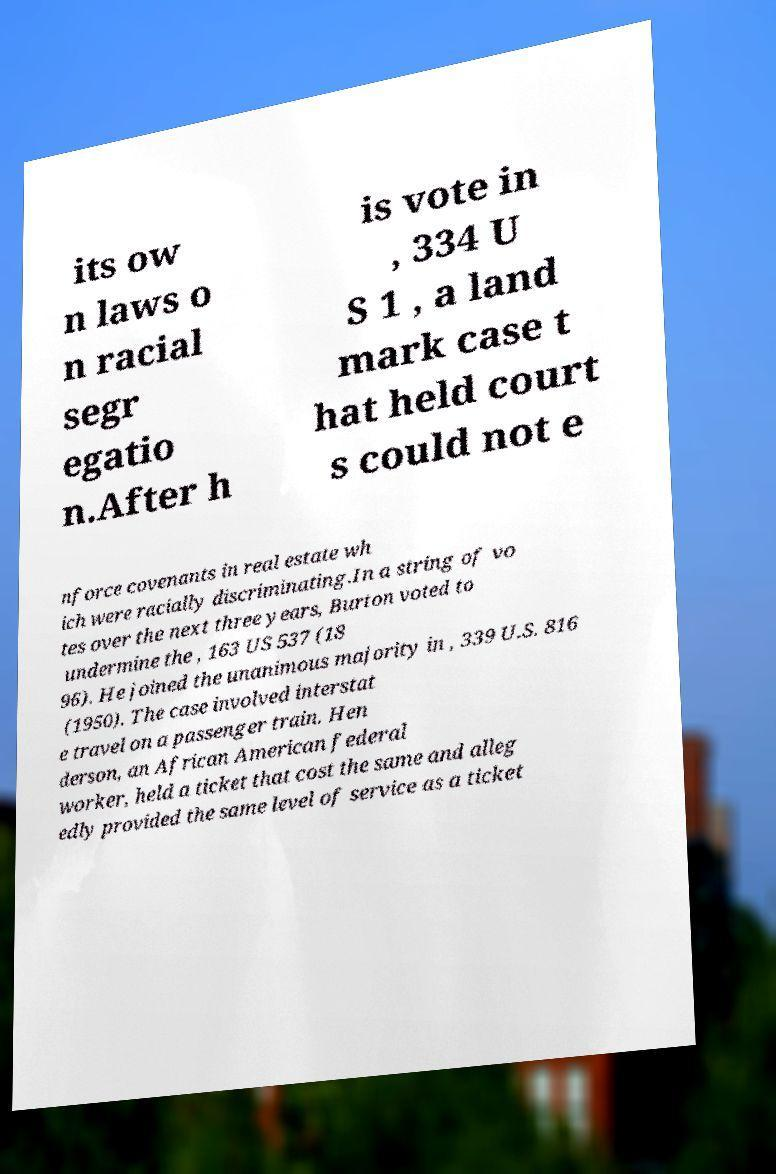Can you read and provide the text displayed in the image?This photo seems to have some interesting text. Can you extract and type it out for me? its ow n laws o n racial segr egatio n.After h is vote in , 334 U S 1 , a land mark case t hat held court s could not e nforce covenants in real estate wh ich were racially discriminating.In a string of vo tes over the next three years, Burton voted to undermine the , 163 US 537 (18 96). He joined the unanimous majority in , 339 U.S. 816 (1950). The case involved interstat e travel on a passenger train. Hen derson, an African American federal worker, held a ticket that cost the same and alleg edly provided the same level of service as a ticket 